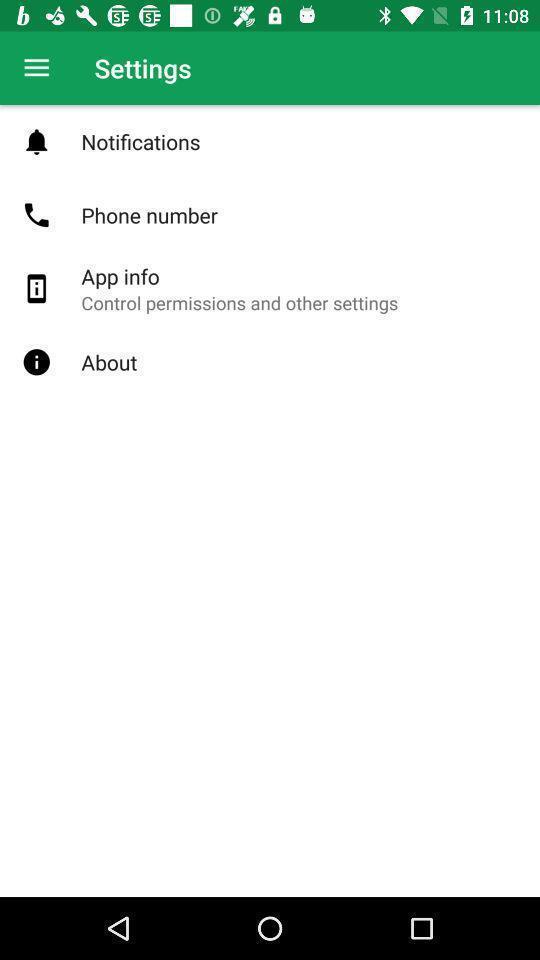Describe this image in words. Settings tab with different types of options. 